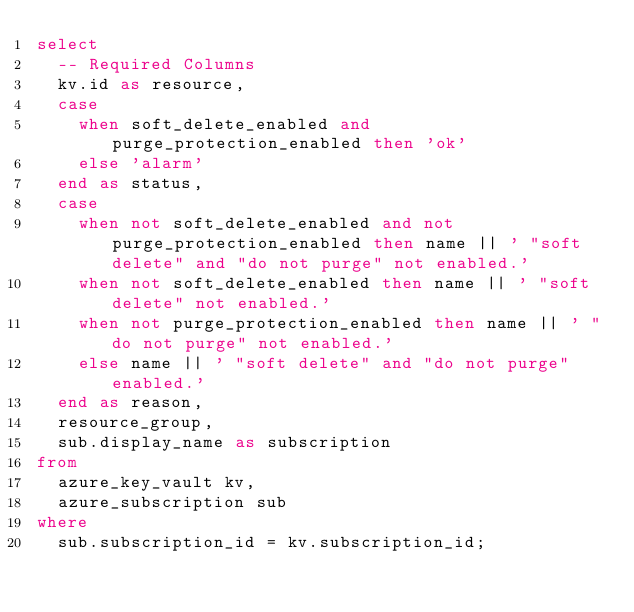Convert code to text. <code><loc_0><loc_0><loc_500><loc_500><_SQL_>select
  -- Required Columns
  kv.id as resource,
  case
    when soft_delete_enabled and purge_protection_enabled then 'ok'
    else 'alarm'
  end as status,
  case
    when not soft_delete_enabled and not purge_protection_enabled then name || ' "soft delete" and "do not purge" not enabled.'
    when not soft_delete_enabled then name || ' "soft delete" not enabled.'
    when not purge_protection_enabled then name || ' "do not purge" not enabled.'
    else name || ' "soft delete" and "do not purge" enabled.'
  end as reason,
  resource_group,
  sub.display_name as subscription
from
  azure_key_vault kv,
  azure_subscription sub
where
  sub.subscription_id = kv.subscription_id;</code> 